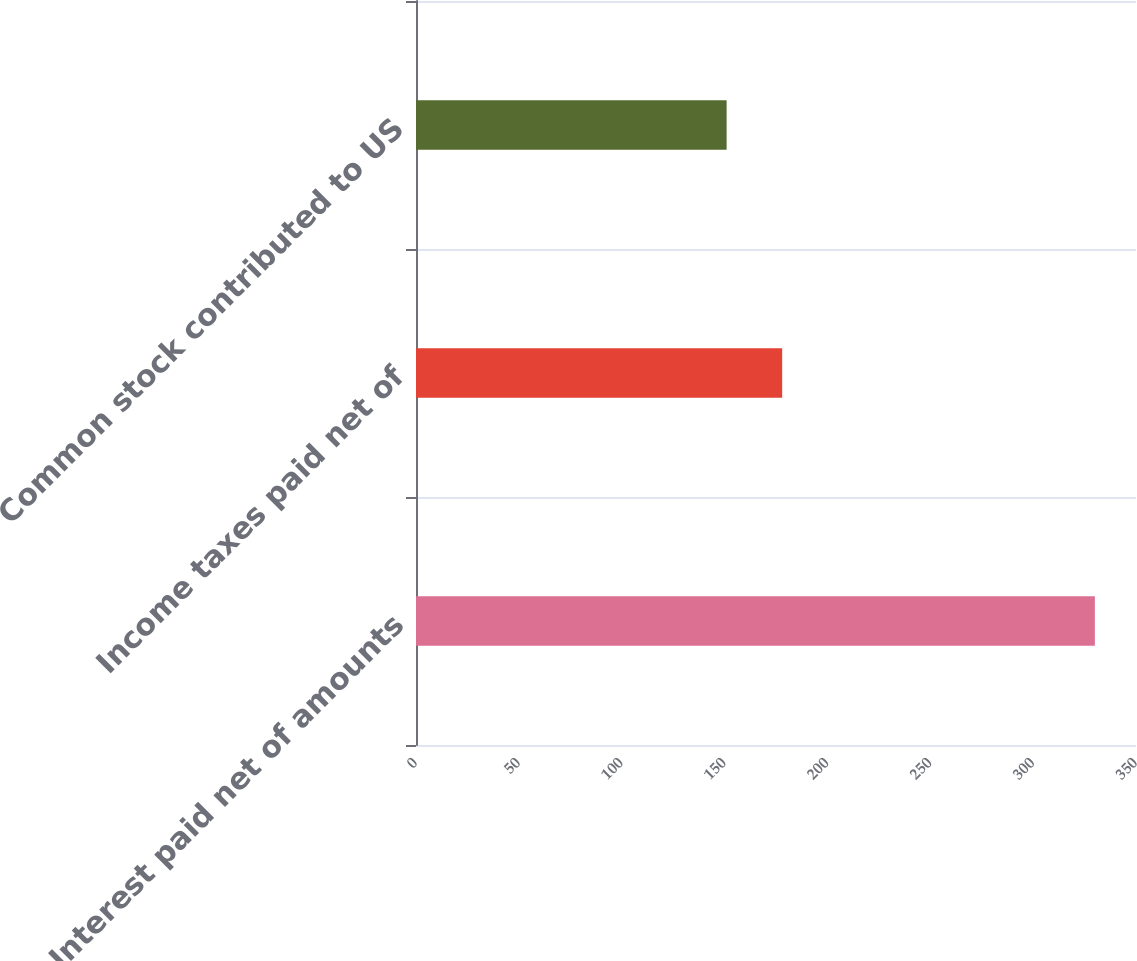Convert chart to OTSL. <chart><loc_0><loc_0><loc_500><loc_500><bar_chart><fcel>Interest paid net of amounts<fcel>Income taxes paid net of<fcel>Common stock contributed to US<nl><fcel>330<fcel>178<fcel>151<nl></chart> 